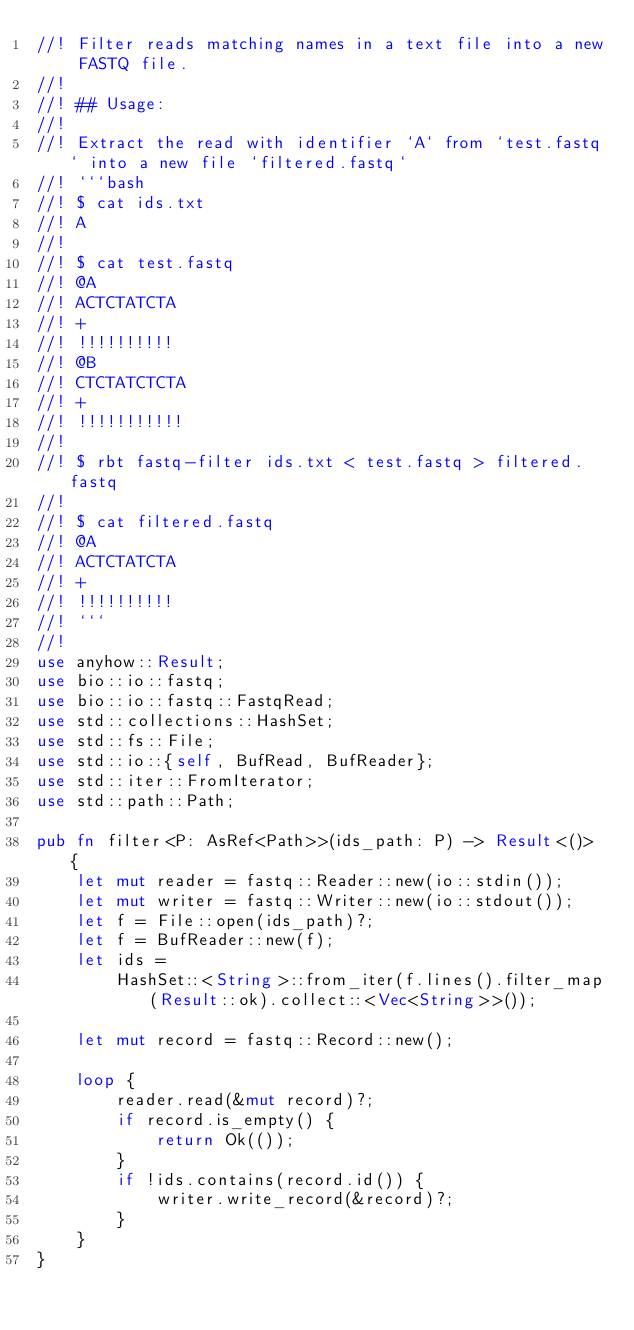Convert code to text. <code><loc_0><loc_0><loc_500><loc_500><_Rust_>//! Filter reads matching names in a text file into a new FASTQ file.
//!
//! ## Usage:
//!
//! Extract the read with identifier `A` from `test.fastq` into a new file `filtered.fastq`
//! ```bash
//! $ cat ids.txt
//! A
//!
//! $ cat test.fastq
//! @A
//! ACTCTATCTA
//! +
//! !!!!!!!!!!
//! @B
//! CTCTATCTCTA
//! +
//! !!!!!!!!!!!
//!
//! $ rbt fastq-filter ids.txt < test.fastq > filtered.fastq
//!
//! $ cat filtered.fastq
//! @A
//! ACTCTATCTA
//! +
//! !!!!!!!!!!
//! ```
//!
use anyhow::Result;
use bio::io::fastq;
use bio::io::fastq::FastqRead;
use std::collections::HashSet;
use std::fs::File;
use std::io::{self, BufRead, BufReader};
use std::iter::FromIterator;
use std::path::Path;

pub fn filter<P: AsRef<Path>>(ids_path: P) -> Result<()> {
    let mut reader = fastq::Reader::new(io::stdin());
    let mut writer = fastq::Writer::new(io::stdout());
    let f = File::open(ids_path)?;
    let f = BufReader::new(f);
    let ids =
        HashSet::<String>::from_iter(f.lines().filter_map(Result::ok).collect::<Vec<String>>());

    let mut record = fastq::Record::new();

    loop {
        reader.read(&mut record)?;
        if record.is_empty() {
            return Ok(());
        }
        if !ids.contains(record.id()) {
            writer.write_record(&record)?;
        }
    }
}
</code> 